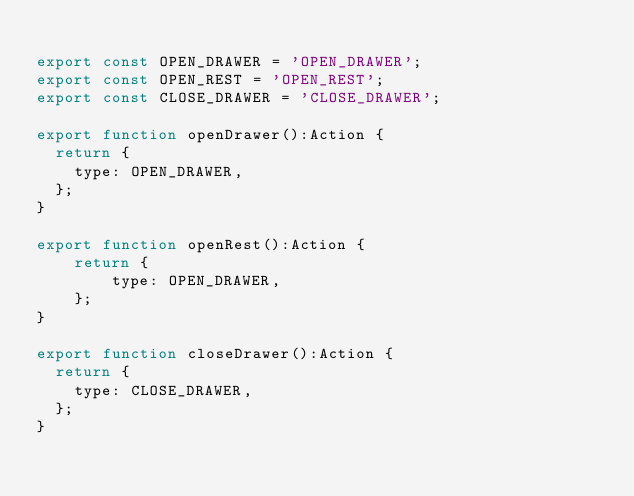<code> <loc_0><loc_0><loc_500><loc_500><_JavaScript_>
export const OPEN_DRAWER = 'OPEN_DRAWER';
export const OPEN_REST = 'OPEN_REST';
export const CLOSE_DRAWER = 'CLOSE_DRAWER';

export function openDrawer():Action {
  return {
    type: OPEN_DRAWER,
  };
}

export function openRest():Action {
    return {
        type: OPEN_DRAWER,
    };
}

export function closeDrawer():Action {
  return {
    type: CLOSE_DRAWER,
  };
}
</code> 